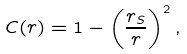Convert formula to latex. <formula><loc_0><loc_0><loc_500><loc_500>C ( r ) = 1 - \left ( \frac { r _ { S } } { r } \right ) ^ { 2 } ,</formula> 